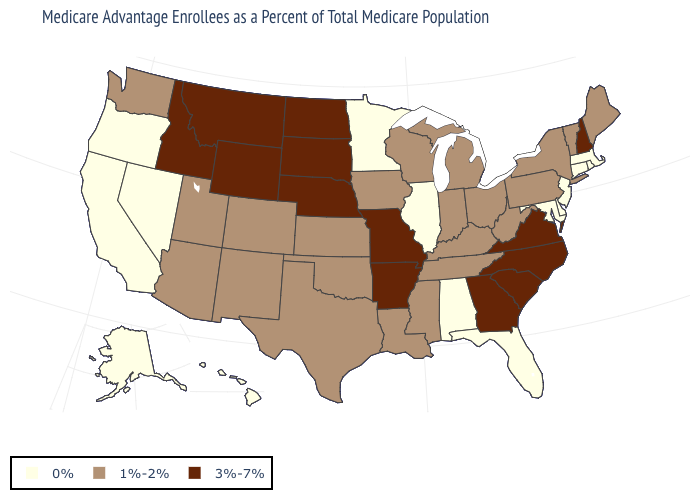Does Maine have the highest value in the USA?
Give a very brief answer. No. What is the value of Kansas?
Be succinct. 1%-2%. How many symbols are there in the legend?
Answer briefly. 3. What is the highest value in the USA?
Quick response, please. 3%-7%. Does Colorado have a lower value than South Dakota?
Write a very short answer. Yes. Name the states that have a value in the range 0%?
Keep it brief. Alaska, Alabama, California, Connecticut, Delaware, Florida, Hawaii, Illinois, Massachusetts, Maryland, Minnesota, New Jersey, Nevada, Oregon, Rhode Island. What is the highest value in the Northeast ?
Give a very brief answer. 3%-7%. Name the states that have a value in the range 1%-2%?
Concise answer only. Arizona, Colorado, Iowa, Indiana, Kansas, Kentucky, Louisiana, Maine, Michigan, Mississippi, New Mexico, New York, Ohio, Oklahoma, Pennsylvania, Tennessee, Texas, Utah, Vermont, Washington, Wisconsin, West Virginia. Does the first symbol in the legend represent the smallest category?
Give a very brief answer. Yes. Does Indiana have the lowest value in the MidWest?
Be succinct. No. Which states have the lowest value in the USA?
Quick response, please. Alaska, Alabama, California, Connecticut, Delaware, Florida, Hawaii, Illinois, Massachusetts, Maryland, Minnesota, New Jersey, Nevada, Oregon, Rhode Island. Among the states that border Iowa , does Nebraska have the lowest value?
Quick response, please. No. What is the highest value in the USA?
Short answer required. 3%-7%. What is the lowest value in the USA?
Answer briefly. 0%. 